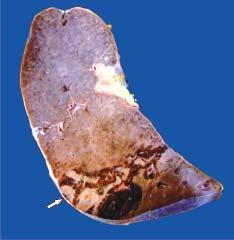what is congested?
Answer the question using a single word or phrase. The margin 